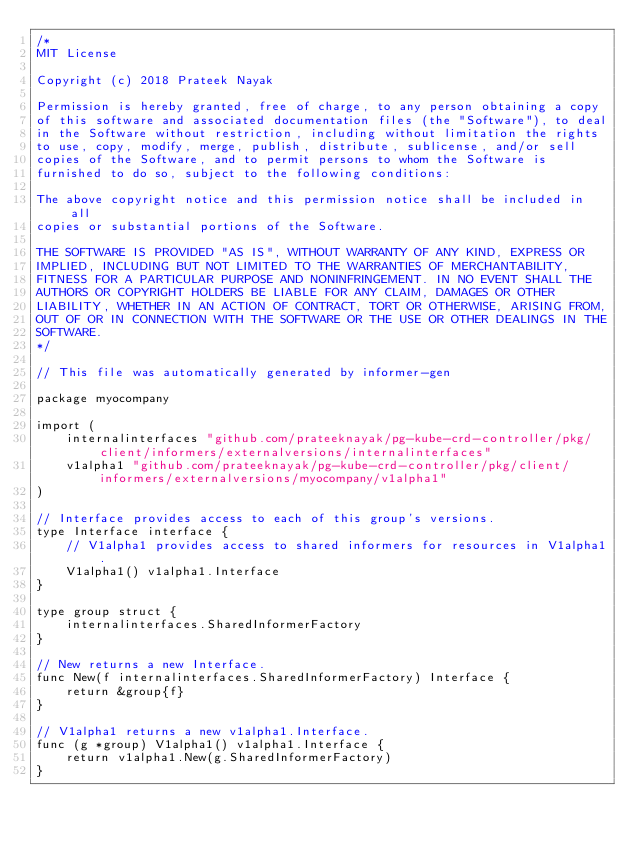Convert code to text. <code><loc_0><loc_0><loc_500><loc_500><_Go_>/*
MIT License

Copyright (c) 2018 Prateek Nayak

Permission is hereby granted, free of charge, to any person obtaining a copy
of this software and associated documentation files (the "Software"), to deal
in the Software without restriction, including without limitation the rights
to use, copy, modify, merge, publish, distribute, sublicense, and/or sell
copies of the Software, and to permit persons to whom the Software is
furnished to do so, subject to the following conditions:

The above copyright notice and this permission notice shall be included in all
copies or substantial portions of the Software.

THE SOFTWARE IS PROVIDED "AS IS", WITHOUT WARRANTY OF ANY KIND, EXPRESS OR
IMPLIED, INCLUDING BUT NOT LIMITED TO THE WARRANTIES OF MERCHANTABILITY,
FITNESS FOR A PARTICULAR PURPOSE AND NONINFRINGEMENT. IN NO EVENT SHALL THE
AUTHORS OR COPYRIGHT HOLDERS BE LIABLE FOR ANY CLAIM, DAMAGES OR OTHER
LIABILITY, WHETHER IN AN ACTION OF CONTRACT, TORT OR OTHERWISE, ARISING FROM,
OUT OF OR IN CONNECTION WITH THE SOFTWARE OR THE USE OR OTHER DEALINGS IN THE
SOFTWARE.
*/

// This file was automatically generated by informer-gen

package myocompany

import (
	internalinterfaces "github.com/prateeknayak/pg-kube-crd-controller/pkg/client/informers/externalversions/internalinterfaces"
	v1alpha1 "github.com/prateeknayak/pg-kube-crd-controller/pkg/client/informers/externalversions/myocompany/v1alpha1"
)

// Interface provides access to each of this group's versions.
type Interface interface {
	// V1alpha1 provides access to shared informers for resources in V1alpha1.
	V1alpha1() v1alpha1.Interface
}

type group struct {
	internalinterfaces.SharedInformerFactory
}

// New returns a new Interface.
func New(f internalinterfaces.SharedInformerFactory) Interface {
	return &group{f}
}

// V1alpha1 returns a new v1alpha1.Interface.
func (g *group) V1alpha1() v1alpha1.Interface {
	return v1alpha1.New(g.SharedInformerFactory)
}
</code> 